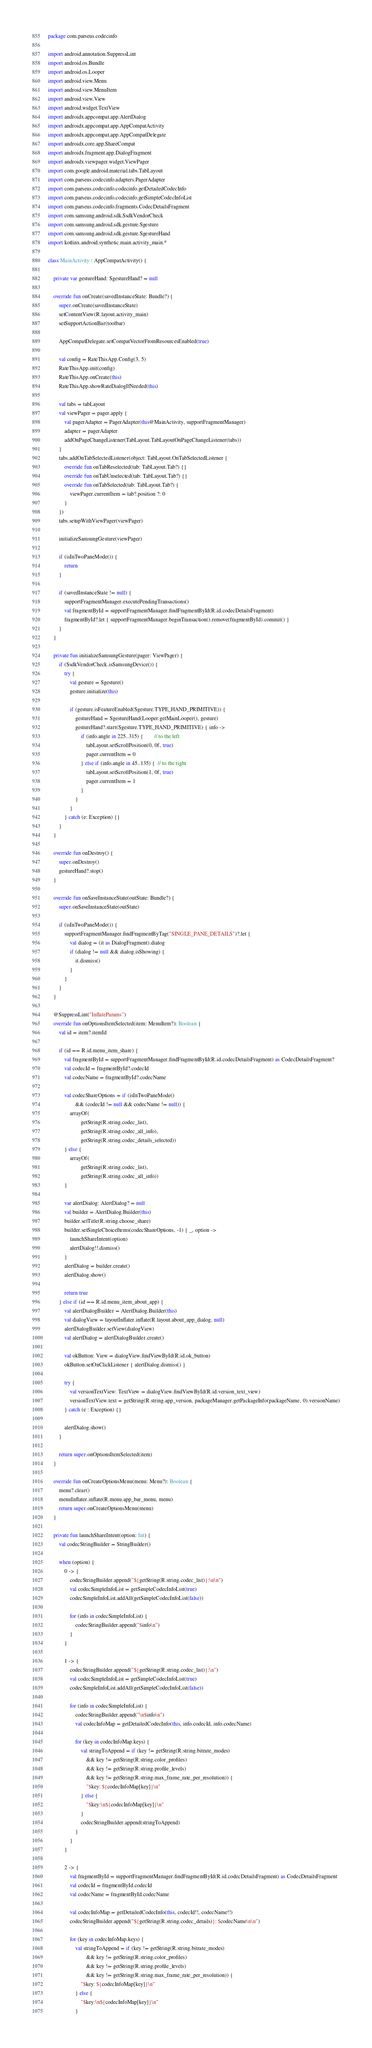Convert code to text. <code><loc_0><loc_0><loc_500><loc_500><_Kotlin_>package com.parseus.codecinfo

import android.annotation.SuppressLint
import android.os.Bundle
import android.os.Looper
import android.view.Menu
import android.view.MenuItem
import android.view.View
import android.widget.TextView
import androidx.appcompat.app.AlertDialog
import androidx.appcompat.app.AppCompatActivity
import androidx.appcompat.app.AppCompatDelegate
import androidx.core.app.ShareCompat
import androidx.fragment.app.DialogFragment
import androidx.viewpager.widget.ViewPager
import com.google.android.material.tabs.TabLayout
import com.parseus.codecinfo.adapters.PagerAdapter
import com.parseus.codecinfo.codecinfo.getDetailedCodecInfo
import com.parseus.codecinfo.codecinfo.getSimpleCodecInfoList
import com.parseus.codecinfo.fragments.CodecDetailsFragment
import com.samsung.android.sdk.SsdkVendorCheck
import com.samsung.android.sdk.gesture.Sgesture
import com.samsung.android.sdk.gesture.SgestureHand
import kotlinx.android.synthetic.main.activity_main.*

class MainActivity : AppCompatActivity() {

    private var gestureHand: SgestureHand? = null

    override fun onCreate(savedInstanceState: Bundle?) {
        super.onCreate(savedInstanceState)
        setContentView(R.layout.activity_main)
        setSupportActionBar(toolbar)

        AppCompatDelegate.setCompatVectorFromResourcesEnabled(true)

        val config = RateThisApp.Config(3, 5)
        RateThisApp.init(config)
        RateThisApp.onCreate(this)
        RateThisApp.showRateDialogIfNeeded(this)

        val tabs = tabLayout
        val viewPager = pager.apply {
            val pagerAdapter = PagerAdapter(this@MainActivity, supportFragmentManager)
            adapter = pagerAdapter
            addOnPageChangeListener(TabLayout.TabLayoutOnPageChangeListener(tabs))
        }
        tabs.addOnTabSelectedListener(object: TabLayout.OnTabSelectedListener {
            override fun onTabReselected(tab: TabLayout.Tab?) {}
            override fun onTabUnselected(tab: TabLayout.Tab?) {}
            override fun onTabSelected(tab: TabLayout.Tab?) {
                viewPager.currentItem = tab?.position ?: 0
            }
        })
        tabs.setupWithViewPager(viewPager)

        initializeSamsungGesture(viewPager)

        if (isInTwoPaneMode()) {
            return
        }

        if (savedInstanceState != null) {
            supportFragmentManager.executePendingTransactions()
            val fragmentById = supportFragmentManager.findFragmentById(R.id.codecDetailsFragment)
            fragmentById?.let { supportFragmentManager.beginTransaction().remove(fragmentById).commit() }
        }
    }

    private fun initializeSamsungGesture(pager: ViewPager) {
        if (SsdkVendorCheck.isSamsungDevice()) {
            try {
                val gesture = Sgesture()
                gesture.initialize(this)

                if (gesture.isFeatureEnabled(Sgesture.TYPE_HAND_PRIMITIVE)) {
                    gestureHand = SgestureHand(Looper.getMainLooper(), gesture)
                    gestureHand?.start(Sgesture.TYPE_HAND_PRIMITIVE) { info ->
                        if (info.angle in 225..315) {        // to the left
                            tabLayout.setScrollPosition(0, 0f, true)
                            pager.currentItem = 0
                        } else if (info.angle in 45..135) {  // to the right
                            tabLayout.setScrollPosition(1, 0f, true)
                            pager.currentItem = 1
                        }
                    }
                }
            } catch (e: Exception) {}
        }
    }

    override fun onDestroy() {
        super.onDestroy()
        gestureHand?.stop()
    }

    override fun onSaveInstanceState(outState: Bundle?) {
        super.onSaveInstanceState(outState)

        if (isInTwoPaneMode()) {
            supportFragmentManager.findFragmentByTag("SINGLE_PANE_DETAILS")?.let {
                val dialog = (it as DialogFragment).dialog
                if (dialog != null && dialog.isShowing) {
                    it.dismiss()
                }
            }
        }
    }

    @SuppressLint("InflateParams")
    override fun onOptionsItemSelected(item: MenuItem?): Boolean {
        val id = item?.itemId

        if (id == R.id.menu_item_share) {
            val fragmentById = supportFragmentManager.findFragmentById(R.id.codecDetailsFragment) as CodecDetailsFragment?
            val codecId = fragmentById?.codecId
            val codecName = fragmentById?.codecName

            val codecShareOptions = if (isInTwoPaneMode()
                    && (codecId != null && codecName != null)) {
                arrayOf(
                        getString(R.string.codec_list),
                        getString(R.string.codec_all_info),
                        getString(R.string.codec_details_selected))
            } else {
                arrayOf(
                        getString(R.string.codec_list),
                        getString(R.string.codec_all_info))
            }

            var alertDialog: AlertDialog? = null
            val builder = AlertDialog.Builder(this)
            builder.setTitle(R.string.choose_share)
            builder.setSingleChoiceItems(codecShareOptions, -1) { _, option ->
                launchShareIntent(option)
                alertDialog!!.dismiss()
            }
            alertDialog = builder.create()
            alertDialog.show()

            return true
        } else if (id == R.id.menu_item_about_app) {
            val alertDialogBuilder = AlertDialog.Builder(this)
            val dialogView = layoutInflater.inflate(R.layout.about_app_dialog, null)
            alertDialogBuilder.setView(dialogView)
            val alertDialog = alertDialogBuilder.create()

            val okButton: View = dialogView.findViewById(R.id.ok_button)
            okButton.setOnClickListener { alertDialog.dismiss() }

            try {
                val versionTextView: TextView = dialogView.findViewById(R.id.version_text_view)
                versionTextView.text = getString(R.string.app_version, packageManager.getPackageInfo(packageName, 0).versionName)
            } catch (e : Exception) {}

            alertDialog.show()
        }

        return super.onOptionsItemSelected(item)
    }

    override fun onCreateOptionsMenu(menu: Menu?): Boolean {
        menu?.clear()
        menuInflater.inflate(R.menu.app_bar_menu, menu)
        return super.onCreateOptionsMenu(menu)
    }

    private fun launchShareIntent(option: Int) {
        val codecStringBuilder = StringBuilder()

        when (option) {
            0 -> {
                codecStringBuilder.append("${getString(R.string.codec_list)}:\n\n")
                val codecSimpleInfoList = getSimpleCodecInfoList(true)
                codecSimpleInfoList.addAll(getSimpleCodecInfoList(false))

                for (info in codecSimpleInfoList) {
                    codecStringBuilder.append("$info\n")
                }
            }

            1 -> {
                codecStringBuilder.append("${getString(R.string.codec_list)}:\n")
                val codecSimpleInfoList = getSimpleCodecInfoList(true)
                codecSimpleInfoList.addAll(getSimpleCodecInfoList(false))

                for (info in codecSimpleInfoList) {
                    codecStringBuilder.append("\n$info\n")
                    val codecInfoMap = getDetailedCodecInfo(this, info.codecId, info.codecName)

                    for (key in codecInfoMap.keys) {
                        val stringToAppend = if (key != getString(R.string.bitrate_modes)
                            && key != getString(R.string.color_profiles)
                            && key != getString(R.string.profile_levels)
                            && key != getString(R.string.max_frame_rate_per_resolution)) {
                            "$key: ${codecInfoMap[key]}\n"
                        } else {
                            "$key:\n${codecInfoMap[key]}\n"
                        }
                        codecStringBuilder.append(stringToAppend)
                    }
                }
            }

            2 -> {
                val fragmentById = supportFragmentManager.findFragmentById(R.id.codecDetailsFragment) as CodecDetailsFragment
                val codecId = fragmentById.codecId
                val codecName = fragmentById.codecName

                val codecInfoMap = getDetailedCodecInfo(this, codecId!!, codecName!!)
                codecStringBuilder.append("${getString(R.string.codec_details)}: $codecName\n\n")

                for (key in codecInfoMap.keys) {
                    val stringToAppend = if (key != getString(R.string.bitrate_modes)
                            && key != getString(R.string.color_profiles)
                            && key != getString(R.string.profile_levels)
                            && key != getString(R.string.max_frame_rate_per_resolution)) {
                        "$key: ${codecInfoMap[key]}\n"
                    } else {
                        "$key:\n${codecInfoMap[key]}\n"
                    }</code> 